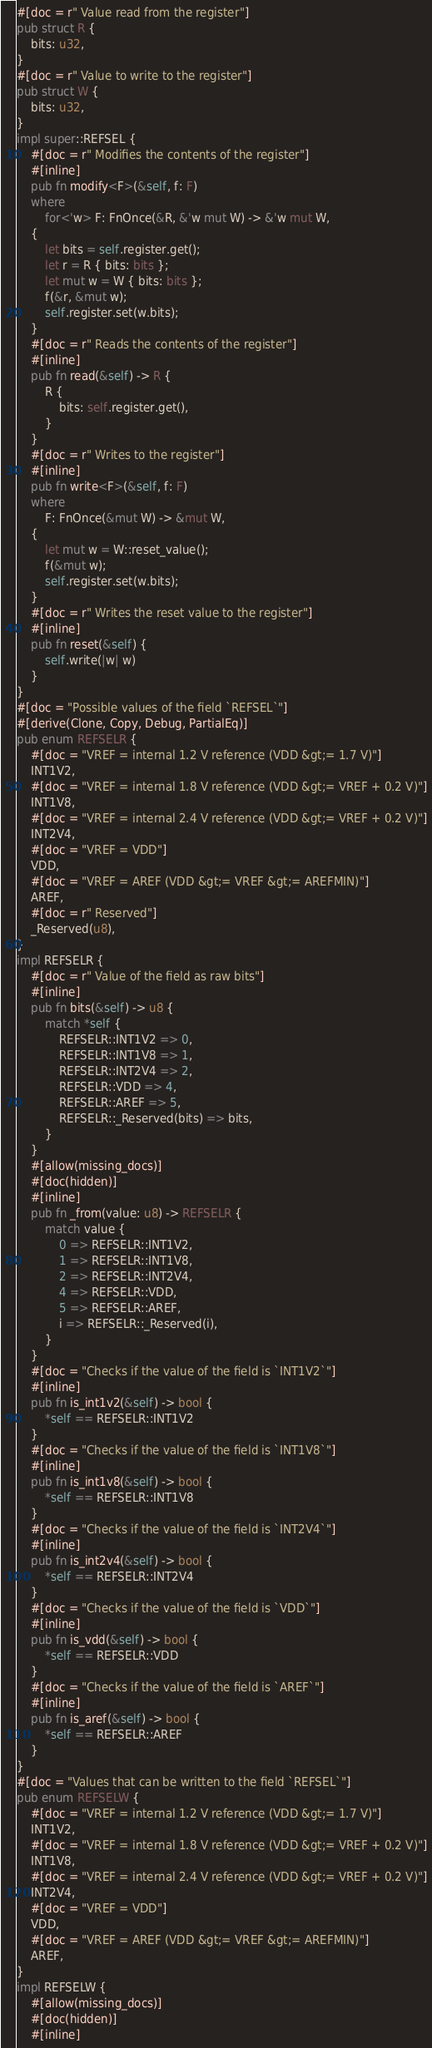<code> <loc_0><loc_0><loc_500><loc_500><_Rust_>#[doc = r" Value read from the register"]
pub struct R {
    bits: u32,
}
#[doc = r" Value to write to the register"]
pub struct W {
    bits: u32,
}
impl super::REFSEL {
    #[doc = r" Modifies the contents of the register"]
    #[inline]
    pub fn modify<F>(&self, f: F)
    where
        for<'w> F: FnOnce(&R, &'w mut W) -> &'w mut W,
    {
        let bits = self.register.get();
        let r = R { bits: bits };
        let mut w = W { bits: bits };
        f(&r, &mut w);
        self.register.set(w.bits);
    }
    #[doc = r" Reads the contents of the register"]
    #[inline]
    pub fn read(&self) -> R {
        R {
            bits: self.register.get(),
        }
    }
    #[doc = r" Writes to the register"]
    #[inline]
    pub fn write<F>(&self, f: F)
    where
        F: FnOnce(&mut W) -> &mut W,
    {
        let mut w = W::reset_value();
        f(&mut w);
        self.register.set(w.bits);
    }
    #[doc = r" Writes the reset value to the register"]
    #[inline]
    pub fn reset(&self) {
        self.write(|w| w)
    }
}
#[doc = "Possible values of the field `REFSEL`"]
#[derive(Clone, Copy, Debug, PartialEq)]
pub enum REFSELR {
    #[doc = "VREF = internal 1.2 V reference (VDD &gt;= 1.7 V)"]
    INT1V2,
    #[doc = "VREF = internal 1.8 V reference (VDD &gt;= VREF + 0.2 V)"]
    INT1V8,
    #[doc = "VREF = internal 2.4 V reference (VDD &gt;= VREF + 0.2 V)"]
    INT2V4,
    #[doc = "VREF = VDD"]
    VDD,
    #[doc = "VREF = AREF (VDD &gt;= VREF &gt;= AREFMIN)"]
    AREF,
    #[doc = r" Reserved"]
    _Reserved(u8),
}
impl REFSELR {
    #[doc = r" Value of the field as raw bits"]
    #[inline]
    pub fn bits(&self) -> u8 {
        match *self {
            REFSELR::INT1V2 => 0,
            REFSELR::INT1V8 => 1,
            REFSELR::INT2V4 => 2,
            REFSELR::VDD => 4,
            REFSELR::AREF => 5,
            REFSELR::_Reserved(bits) => bits,
        }
    }
    #[allow(missing_docs)]
    #[doc(hidden)]
    #[inline]
    pub fn _from(value: u8) -> REFSELR {
        match value {
            0 => REFSELR::INT1V2,
            1 => REFSELR::INT1V8,
            2 => REFSELR::INT2V4,
            4 => REFSELR::VDD,
            5 => REFSELR::AREF,
            i => REFSELR::_Reserved(i),
        }
    }
    #[doc = "Checks if the value of the field is `INT1V2`"]
    #[inline]
    pub fn is_int1v2(&self) -> bool {
        *self == REFSELR::INT1V2
    }
    #[doc = "Checks if the value of the field is `INT1V8`"]
    #[inline]
    pub fn is_int1v8(&self) -> bool {
        *self == REFSELR::INT1V8
    }
    #[doc = "Checks if the value of the field is `INT2V4`"]
    #[inline]
    pub fn is_int2v4(&self) -> bool {
        *self == REFSELR::INT2V4
    }
    #[doc = "Checks if the value of the field is `VDD`"]
    #[inline]
    pub fn is_vdd(&self) -> bool {
        *self == REFSELR::VDD
    }
    #[doc = "Checks if the value of the field is `AREF`"]
    #[inline]
    pub fn is_aref(&self) -> bool {
        *self == REFSELR::AREF
    }
}
#[doc = "Values that can be written to the field `REFSEL`"]
pub enum REFSELW {
    #[doc = "VREF = internal 1.2 V reference (VDD &gt;= 1.7 V)"]
    INT1V2,
    #[doc = "VREF = internal 1.8 V reference (VDD &gt;= VREF + 0.2 V)"]
    INT1V8,
    #[doc = "VREF = internal 2.4 V reference (VDD &gt;= VREF + 0.2 V)"]
    INT2V4,
    #[doc = "VREF = VDD"]
    VDD,
    #[doc = "VREF = AREF (VDD &gt;= VREF &gt;= AREFMIN)"]
    AREF,
}
impl REFSELW {
    #[allow(missing_docs)]
    #[doc(hidden)]
    #[inline]</code> 